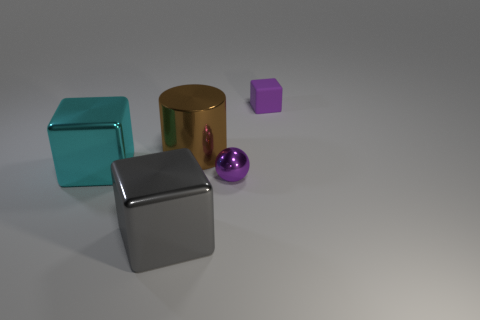What might be the purpose of arranging these objects together? This arrangement of objects could serve multiple purposes. It could be a visual study of form and color, a setup for an artistic composition, or a test render for 3D modeling and texturing techniques. Each object's distinct shape, texture, and color showcase different attributes that contrast and complement each other within the scene. 